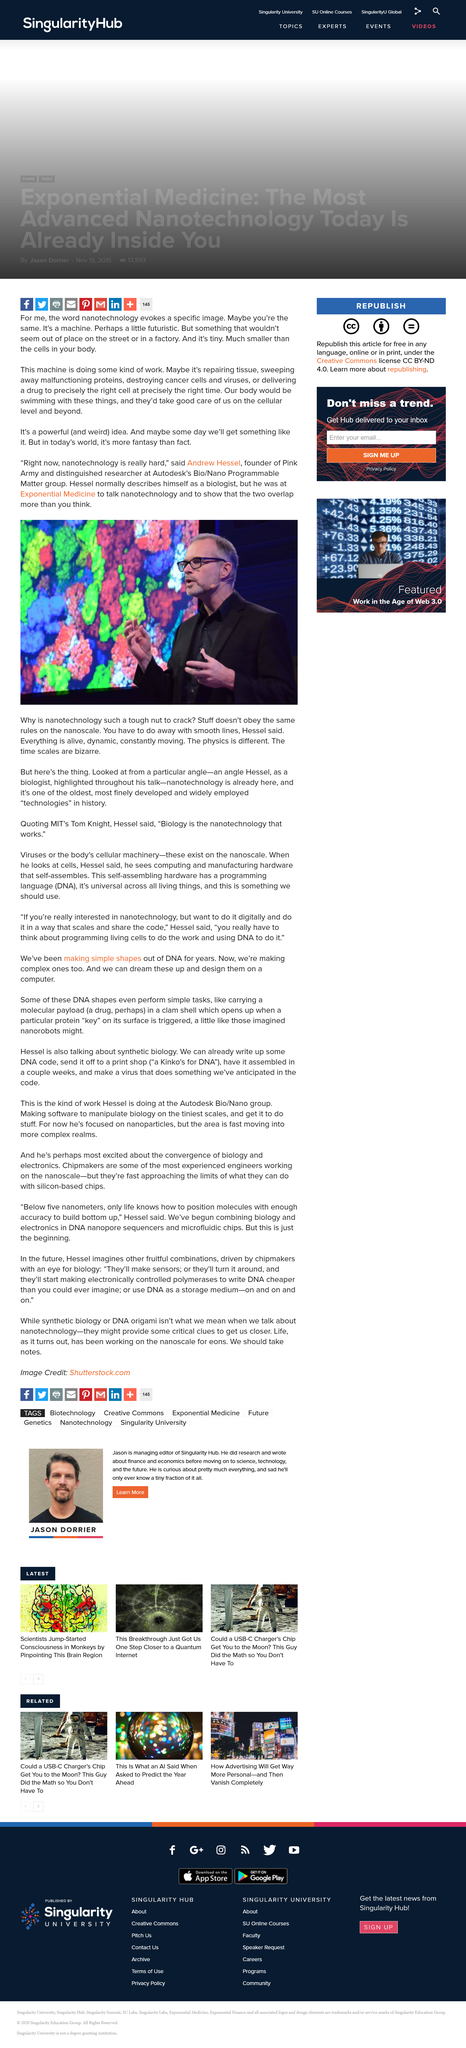Give some essential details in this illustration. Andrew Hesser is the founder of the Pink Army. Andrew Hessel conducts his research at the Bio/Nano Programmable Matter group of Autodesk. Hessel is a biologist. 